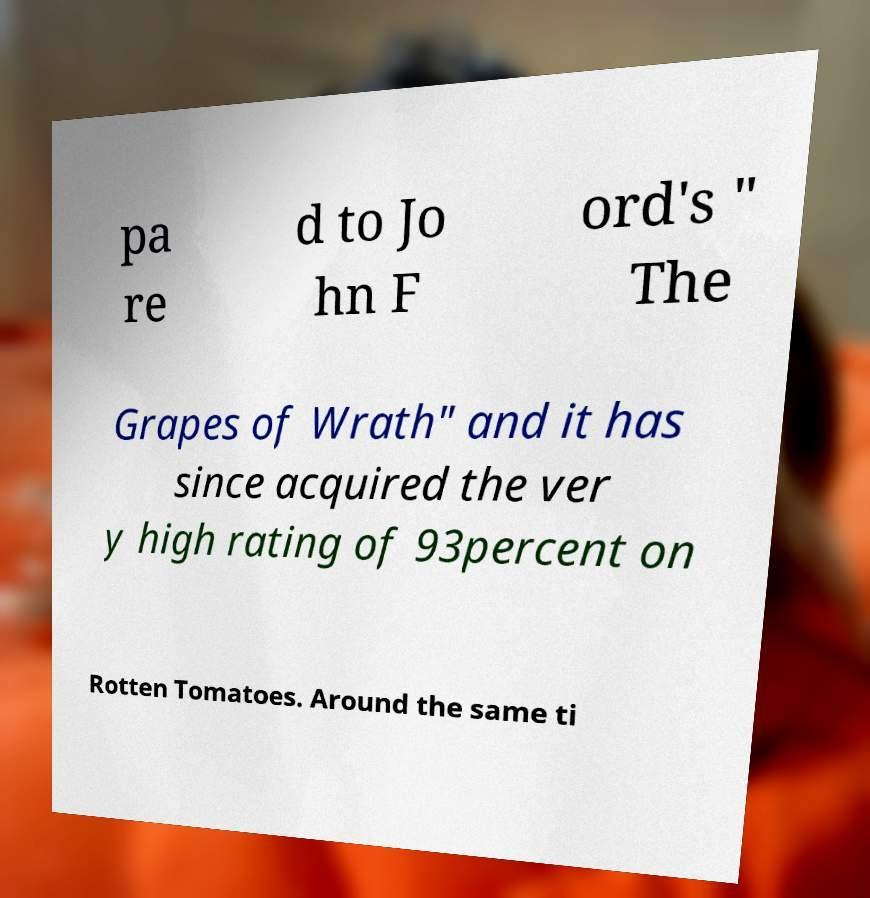Can you read and provide the text displayed in the image?This photo seems to have some interesting text. Can you extract and type it out for me? pa re d to Jo hn F ord's " The Grapes of Wrath" and it has since acquired the ver y high rating of 93percent on Rotten Tomatoes. Around the same ti 